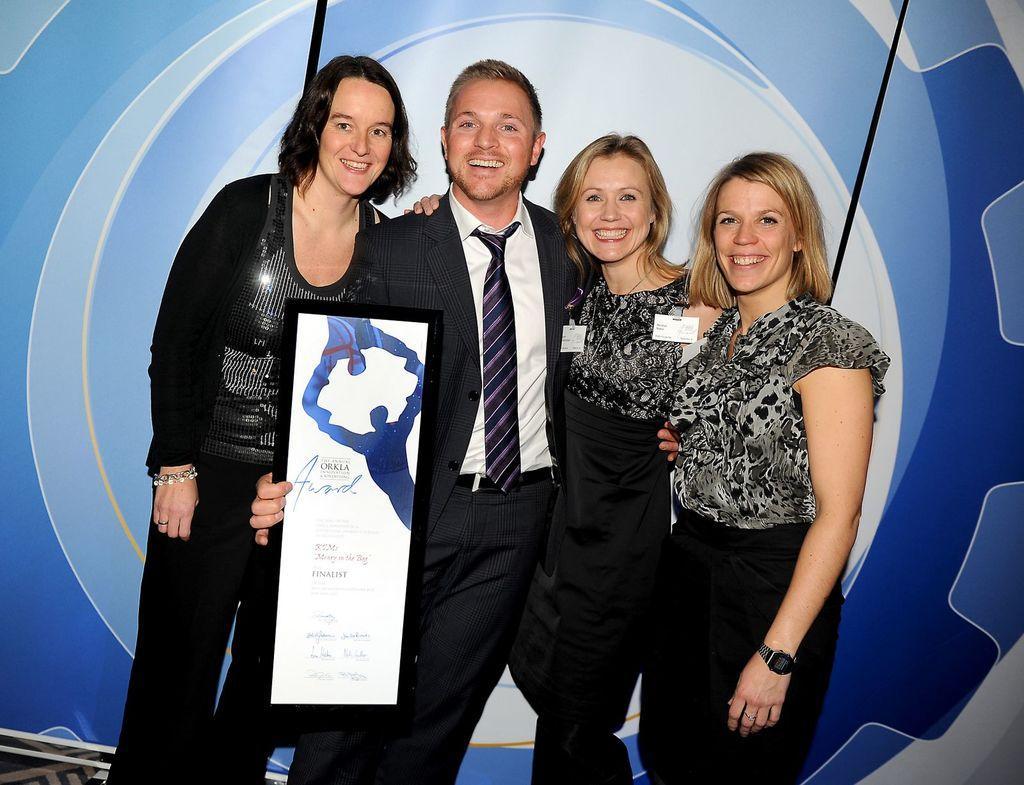In one or two sentences, can you explain what this image depicts? In the center of this picture we can see a man wearing suit, holding an object, smiling and standing and we can see the group of women smiling and standing. In the background we can see the ropes and some other objects. 